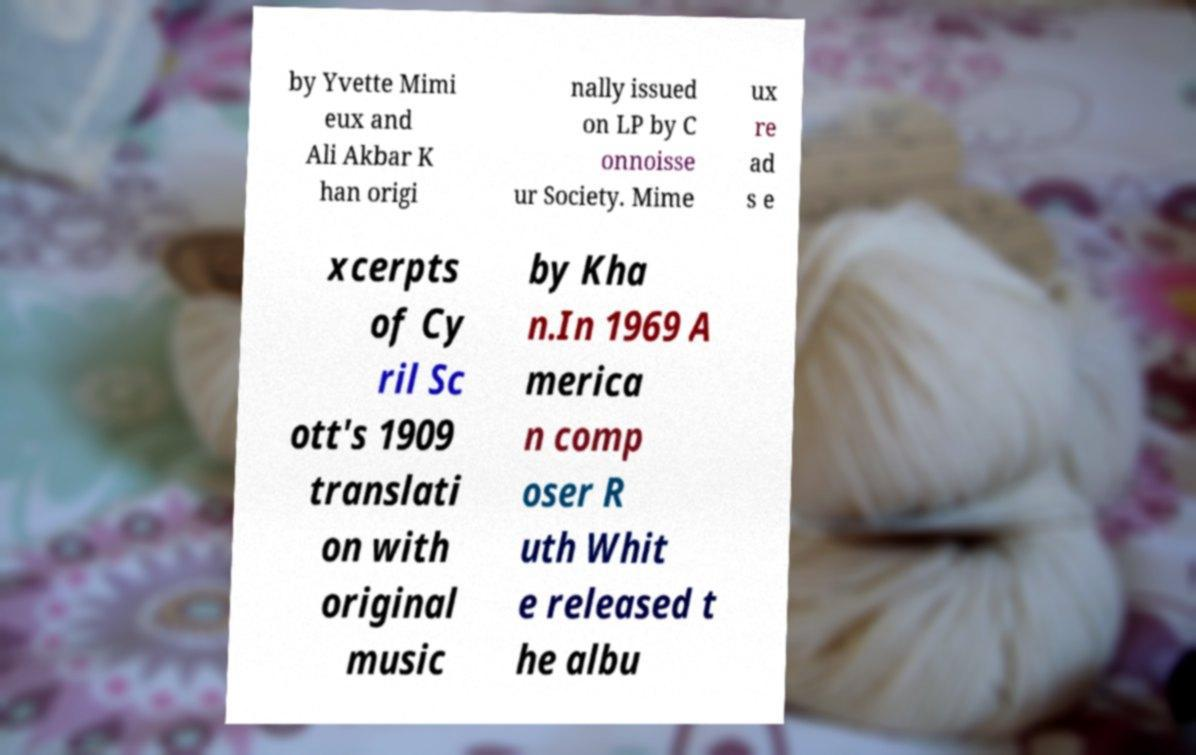Please identify and transcribe the text found in this image. by Yvette Mimi eux and Ali Akbar K han origi nally issued on LP by C onnoisse ur Society. Mime ux re ad s e xcerpts of Cy ril Sc ott's 1909 translati on with original music by Kha n.In 1969 A merica n comp oser R uth Whit e released t he albu 